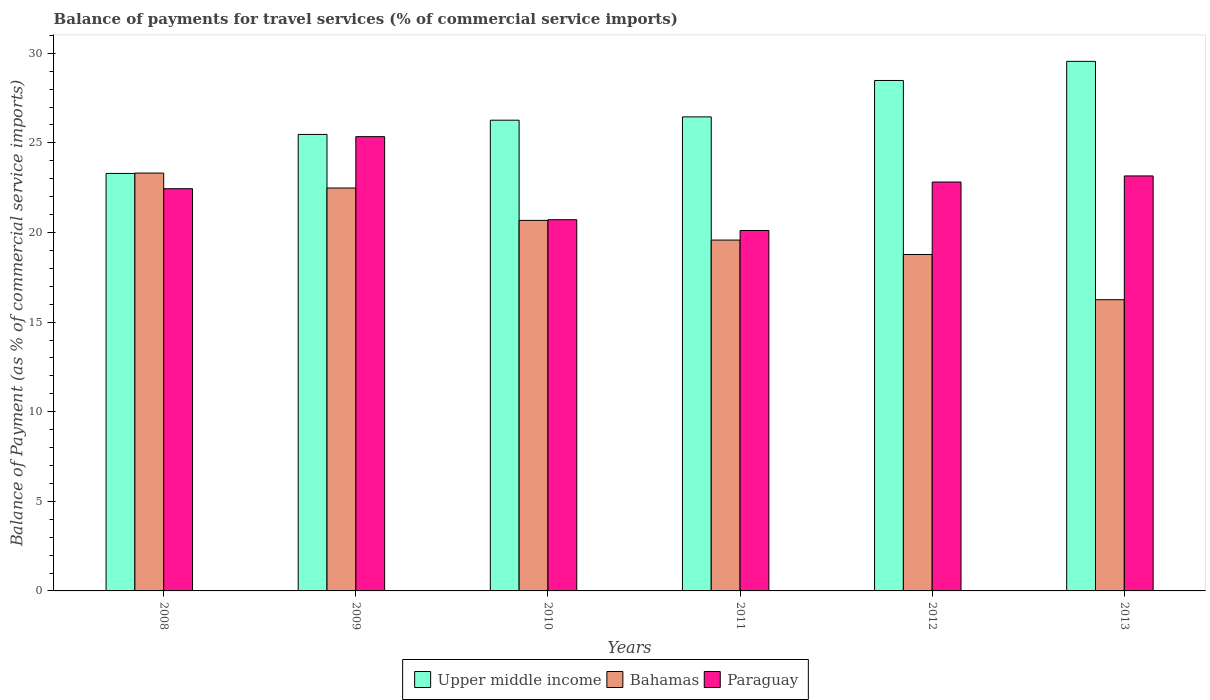How many different coloured bars are there?
Offer a terse response. 3. Are the number of bars on each tick of the X-axis equal?
Your answer should be compact. Yes. What is the label of the 3rd group of bars from the left?
Make the answer very short. 2010. What is the balance of payments for travel services in Paraguay in 2013?
Your answer should be compact. 23.16. Across all years, what is the maximum balance of payments for travel services in Bahamas?
Provide a succinct answer. 23.32. Across all years, what is the minimum balance of payments for travel services in Paraguay?
Provide a short and direct response. 20.11. In which year was the balance of payments for travel services in Upper middle income minimum?
Your answer should be very brief. 2008. What is the total balance of payments for travel services in Bahamas in the graph?
Your answer should be very brief. 121.08. What is the difference between the balance of payments for travel services in Upper middle income in 2009 and that in 2013?
Your answer should be very brief. -4.08. What is the difference between the balance of payments for travel services in Bahamas in 2008 and the balance of payments for travel services in Paraguay in 2011?
Your answer should be compact. 3.2. What is the average balance of payments for travel services in Paraguay per year?
Give a very brief answer. 22.43. In the year 2009, what is the difference between the balance of payments for travel services in Bahamas and balance of payments for travel services in Paraguay?
Your answer should be very brief. -2.87. In how many years, is the balance of payments for travel services in Bahamas greater than 19 %?
Your answer should be compact. 4. What is the ratio of the balance of payments for travel services in Bahamas in 2008 to that in 2011?
Provide a succinct answer. 1.19. Is the difference between the balance of payments for travel services in Bahamas in 2009 and 2012 greater than the difference between the balance of payments for travel services in Paraguay in 2009 and 2012?
Give a very brief answer. Yes. What is the difference between the highest and the second highest balance of payments for travel services in Upper middle income?
Offer a terse response. 1.07. What is the difference between the highest and the lowest balance of payments for travel services in Bahamas?
Your answer should be very brief. 7.07. What does the 1st bar from the left in 2012 represents?
Provide a succinct answer. Upper middle income. What does the 2nd bar from the right in 2013 represents?
Make the answer very short. Bahamas. How many bars are there?
Provide a short and direct response. 18. Are all the bars in the graph horizontal?
Your response must be concise. No. What is the difference between two consecutive major ticks on the Y-axis?
Keep it short and to the point. 5. Are the values on the major ticks of Y-axis written in scientific E-notation?
Make the answer very short. No. What is the title of the graph?
Make the answer very short. Balance of payments for travel services (% of commercial service imports). Does "Euro area" appear as one of the legend labels in the graph?
Make the answer very short. No. What is the label or title of the Y-axis?
Your response must be concise. Balance of Payment (as % of commercial service imports). What is the Balance of Payment (as % of commercial service imports) in Upper middle income in 2008?
Keep it short and to the point. 23.3. What is the Balance of Payment (as % of commercial service imports) in Bahamas in 2008?
Provide a succinct answer. 23.32. What is the Balance of Payment (as % of commercial service imports) in Paraguay in 2008?
Make the answer very short. 22.44. What is the Balance of Payment (as % of commercial service imports) in Upper middle income in 2009?
Give a very brief answer. 25.47. What is the Balance of Payment (as % of commercial service imports) in Bahamas in 2009?
Provide a succinct answer. 22.48. What is the Balance of Payment (as % of commercial service imports) in Paraguay in 2009?
Your response must be concise. 25.35. What is the Balance of Payment (as % of commercial service imports) in Upper middle income in 2010?
Ensure brevity in your answer.  26.27. What is the Balance of Payment (as % of commercial service imports) in Bahamas in 2010?
Your response must be concise. 20.68. What is the Balance of Payment (as % of commercial service imports) of Paraguay in 2010?
Offer a very short reply. 20.71. What is the Balance of Payment (as % of commercial service imports) in Upper middle income in 2011?
Provide a short and direct response. 26.45. What is the Balance of Payment (as % of commercial service imports) of Bahamas in 2011?
Provide a short and direct response. 19.58. What is the Balance of Payment (as % of commercial service imports) in Paraguay in 2011?
Provide a short and direct response. 20.11. What is the Balance of Payment (as % of commercial service imports) of Upper middle income in 2012?
Your response must be concise. 28.48. What is the Balance of Payment (as % of commercial service imports) in Bahamas in 2012?
Offer a terse response. 18.77. What is the Balance of Payment (as % of commercial service imports) of Paraguay in 2012?
Provide a short and direct response. 22.82. What is the Balance of Payment (as % of commercial service imports) of Upper middle income in 2013?
Provide a succinct answer. 29.55. What is the Balance of Payment (as % of commercial service imports) of Bahamas in 2013?
Provide a succinct answer. 16.25. What is the Balance of Payment (as % of commercial service imports) of Paraguay in 2013?
Make the answer very short. 23.16. Across all years, what is the maximum Balance of Payment (as % of commercial service imports) in Upper middle income?
Make the answer very short. 29.55. Across all years, what is the maximum Balance of Payment (as % of commercial service imports) in Bahamas?
Offer a terse response. 23.32. Across all years, what is the maximum Balance of Payment (as % of commercial service imports) in Paraguay?
Make the answer very short. 25.35. Across all years, what is the minimum Balance of Payment (as % of commercial service imports) in Upper middle income?
Your answer should be compact. 23.3. Across all years, what is the minimum Balance of Payment (as % of commercial service imports) in Bahamas?
Make the answer very short. 16.25. Across all years, what is the minimum Balance of Payment (as % of commercial service imports) in Paraguay?
Give a very brief answer. 20.11. What is the total Balance of Payment (as % of commercial service imports) in Upper middle income in the graph?
Offer a terse response. 159.52. What is the total Balance of Payment (as % of commercial service imports) in Bahamas in the graph?
Offer a very short reply. 121.08. What is the total Balance of Payment (as % of commercial service imports) of Paraguay in the graph?
Provide a short and direct response. 134.59. What is the difference between the Balance of Payment (as % of commercial service imports) in Upper middle income in 2008 and that in 2009?
Provide a short and direct response. -2.18. What is the difference between the Balance of Payment (as % of commercial service imports) in Bahamas in 2008 and that in 2009?
Provide a short and direct response. 0.83. What is the difference between the Balance of Payment (as % of commercial service imports) in Paraguay in 2008 and that in 2009?
Provide a succinct answer. -2.9. What is the difference between the Balance of Payment (as % of commercial service imports) of Upper middle income in 2008 and that in 2010?
Your answer should be very brief. -2.97. What is the difference between the Balance of Payment (as % of commercial service imports) of Bahamas in 2008 and that in 2010?
Provide a succinct answer. 2.64. What is the difference between the Balance of Payment (as % of commercial service imports) of Paraguay in 2008 and that in 2010?
Offer a terse response. 1.73. What is the difference between the Balance of Payment (as % of commercial service imports) in Upper middle income in 2008 and that in 2011?
Your answer should be very brief. -3.15. What is the difference between the Balance of Payment (as % of commercial service imports) of Bahamas in 2008 and that in 2011?
Provide a succinct answer. 3.74. What is the difference between the Balance of Payment (as % of commercial service imports) in Paraguay in 2008 and that in 2011?
Your answer should be compact. 2.33. What is the difference between the Balance of Payment (as % of commercial service imports) of Upper middle income in 2008 and that in 2012?
Offer a very short reply. -5.19. What is the difference between the Balance of Payment (as % of commercial service imports) of Bahamas in 2008 and that in 2012?
Keep it short and to the point. 4.54. What is the difference between the Balance of Payment (as % of commercial service imports) of Paraguay in 2008 and that in 2012?
Your answer should be compact. -0.37. What is the difference between the Balance of Payment (as % of commercial service imports) of Upper middle income in 2008 and that in 2013?
Your response must be concise. -6.25. What is the difference between the Balance of Payment (as % of commercial service imports) of Bahamas in 2008 and that in 2013?
Keep it short and to the point. 7.07. What is the difference between the Balance of Payment (as % of commercial service imports) of Paraguay in 2008 and that in 2013?
Your answer should be very brief. -0.71. What is the difference between the Balance of Payment (as % of commercial service imports) in Upper middle income in 2009 and that in 2010?
Your answer should be compact. -0.79. What is the difference between the Balance of Payment (as % of commercial service imports) in Bahamas in 2009 and that in 2010?
Your answer should be very brief. 1.81. What is the difference between the Balance of Payment (as % of commercial service imports) in Paraguay in 2009 and that in 2010?
Give a very brief answer. 4.64. What is the difference between the Balance of Payment (as % of commercial service imports) of Upper middle income in 2009 and that in 2011?
Your answer should be compact. -0.98. What is the difference between the Balance of Payment (as % of commercial service imports) in Bahamas in 2009 and that in 2011?
Provide a succinct answer. 2.91. What is the difference between the Balance of Payment (as % of commercial service imports) in Paraguay in 2009 and that in 2011?
Your response must be concise. 5.24. What is the difference between the Balance of Payment (as % of commercial service imports) of Upper middle income in 2009 and that in 2012?
Provide a succinct answer. -3.01. What is the difference between the Balance of Payment (as % of commercial service imports) of Bahamas in 2009 and that in 2012?
Make the answer very short. 3.71. What is the difference between the Balance of Payment (as % of commercial service imports) in Paraguay in 2009 and that in 2012?
Provide a short and direct response. 2.53. What is the difference between the Balance of Payment (as % of commercial service imports) of Upper middle income in 2009 and that in 2013?
Give a very brief answer. -4.08. What is the difference between the Balance of Payment (as % of commercial service imports) of Bahamas in 2009 and that in 2013?
Your answer should be compact. 6.23. What is the difference between the Balance of Payment (as % of commercial service imports) of Paraguay in 2009 and that in 2013?
Your answer should be very brief. 2.19. What is the difference between the Balance of Payment (as % of commercial service imports) of Upper middle income in 2010 and that in 2011?
Your answer should be very brief. -0.18. What is the difference between the Balance of Payment (as % of commercial service imports) in Bahamas in 2010 and that in 2011?
Ensure brevity in your answer.  1.1. What is the difference between the Balance of Payment (as % of commercial service imports) of Paraguay in 2010 and that in 2011?
Provide a succinct answer. 0.6. What is the difference between the Balance of Payment (as % of commercial service imports) of Upper middle income in 2010 and that in 2012?
Provide a short and direct response. -2.22. What is the difference between the Balance of Payment (as % of commercial service imports) in Bahamas in 2010 and that in 2012?
Your response must be concise. 1.9. What is the difference between the Balance of Payment (as % of commercial service imports) of Paraguay in 2010 and that in 2012?
Offer a terse response. -2.1. What is the difference between the Balance of Payment (as % of commercial service imports) of Upper middle income in 2010 and that in 2013?
Ensure brevity in your answer.  -3.28. What is the difference between the Balance of Payment (as % of commercial service imports) of Bahamas in 2010 and that in 2013?
Offer a terse response. 4.43. What is the difference between the Balance of Payment (as % of commercial service imports) of Paraguay in 2010 and that in 2013?
Provide a succinct answer. -2.44. What is the difference between the Balance of Payment (as % of commercial service imports) in Upper middle income in 2011 and that in 2012?
Keep it short and to the point. -2.03. What is the difference between the Balance of Payment (as % of commercial service imports) of Bahamas in 2011 and that in 2012?
Your answer should be very brief. 0.8. What is the difference between the Balance of Payment (as % of commercial service imports) of Paraguay in 2011 and that in 2012?
Offer a very short reply. -2.71. What is the difference between the Balance of Payment (as % of commercial service imports) of Upper middle income in 2011 and that in 2013?
Provide a short and direct response. -3.1. What is the difference between the Balance of Payment (as % of commercial service imports) in Bahamas in 2011 and that in 2013?
Give a very brief answer. 3.33. What is the difference between the Balance of Payment (as % of commercial service imports) in Paraguay in 2011 and that in 2013?
Keep it short and to the point. -3.04. What is the difference between the Balance of Payment (as % of commercial service imports) in Upper middle income in 2012 and that in 2013?
Ensure brevity in your answer.  -1.07. What is the difference between the Balance of Payment (as % of commercial service imports) of Bahamas in 2012 and that in 2013?
Offer a very short reply. 2.52. What is the difference between the Balance of Payment (as % of commercial service imports) of Paraguay in 2012 and that in 2013?
Your answer should be very brief. -0.34. What is the difference between the Balance of Payment (as % of commercial service imports) of Upper middle income in 2008 and the Balance of Payment (as % of commercial service imports) of Bahamas in 2009?
Give a very brief answer. 0.81. What is the difference between the Balance of Payment (as % of commercial service imports) in Upper middle income in 2008 and the Balance of Payment (as % of commercial service imports) in Paraguay in 2009?
Provide a succinct answer. -2.05. What is the difference between the Balance of Payment (as % of commercial service imports) in Bahamas in 2008 and the Balance of Payment (as % of commercial service imports) in Paraguay in 2009?
Provide a succinct answer. -2.03. What is the difference between the Balance of Payment (as % of commercial service imports) in Upper middle income in 2008 and the Balance of Payment (as % of commercial service imports) in Bahamas in 2010?
Your answer should be very brief. 2.62. What is the difference between the Balance of Payment (as % of commercial service imports) of Upper middle income in 2008 and the Balance of Payment (as % of commercial service imports) of Paraguay in 2010?
Give a very brief answer. 2.58. What is the difference between the Balance of Payment (as % of commercial service imports) in Bahamas in 2008 and the Balance of Payment (as % of commercial service imports) in Paraguay in 2010?
Make the answer very short. 2.6. What is the difference between the Balance of Payment (as % of commercial service imports) in Upper middle income in 2008 and the Balance of Payment (as % of commercial service imports) in Bahamas in 2011?
Your response must be concise. 3.72. What is the difference between the Balance of Payment (as % of commercial service imports) in Upper middle income in 2008 and the Balance of Payment (as % of commercial service imports) in Paraguay in 2011?
Provide a short and direct response. 3.18. What is the difference between the Balance of Payment (as % of commercial service imports) of Bahamas in 2008 and the Balance of Payment (as % of commercial service imports) of Paraguay in 2011?
Ensure brevity in your answer.  3.2. What is the difference between the Balance of Payment (as % of commercial service imports) in Upper middle income in 2008 and the Balance of Payment (as % of commercial service imports) in Bahamas in 2012?
Your answer should be very brief. 4.52. What is the difference between the Balance of Payment (as % of commercial service imports) in Upper middle income in 2008 and the Balance of Payment (as % of commercial service imports) in Paraguay in 2012?
Your answer should be compact. 0.48. What is the difference between the Balance of Payment (as % of commercial service imports) in Bahamas in 2008 and the Balance of Payment (as % of commercial service imports) in Paraguay in 2012?
Provide a succinct answer. 0.5. What is the difference between the Balance of Payment (as % of commercial service imports) in Upper middle income in 2008 and the Balance of Payment (as % of commercial service imports) in Bahamas in 2013?
Offer a very short reply. 7.05. What is the difference between the Balance of Payment (as % of commercial service imports) of Upper middle income in 2008 and the Balance of Payment (as % of commercial service imports) of Paraguay in 2013?
Offer a very short reply. 0.14. What is the difference between the Balance of Payment (as % of commercial service imports) in Bahamas in 2008 and the Balance of Payment (as % of commercial service imports) in Paraguay in 2013?
Offer a very short reply. 0.16. What is the difference between the Balance of Payment (as % of commercial service imports) of Upper middle income in 2009 and the Balance of Payment (as % of commercial service imports) of Bahamas in 2010?
Your answer should be very brief. 4.8. What is the difference between the Balance of Payment (as % of commercial service imports) of Upper middle income in 2009 and the Balance of Payment (as % of commercial service imports) of Paraguay in 2010?
Your response must be concise. 4.76. What is the difference between the Balance of Payment (as % of commercial service imports) of Bahamas in 2009 and the Balance of Payment (as % of commercial service imports) of Paraguay in 2010?
Give a very brief answer. 1.77. What is the difference between the Balance of Payment (as % of commercial service imports) of Upper middle income in 2009 and the Balance of Payment (as % of commercial service imports) of Bahamas in 2011?
Your answer should be very brief. 5.89. What is the difference between the Balance of Payment (as % of commercial service imports) of Upper middle income in 2009 and the Balance of Payment (as % of commercial service imports) of Paraguay in 2011?
Give a very brief answer. 5.36. What is the difference between the Balance of Payment (as % of commercial service imports) of Bahamas in 2009 and the Balance of Payment (as % of commercial service imports) of Paraguay in 2011?
Offer a terse response. 2.37. What is the difference between the Balance of Payment (as % of commercial service imports) of Upper middle income in 2009 and the Balance of Payment (as % of commercial service imports) of Bahamas in 2012?
Your answer should be very brief. 6.7. What is the difference between the Balance of Payment (as % of commercial service imports) in Upper middle income in 2009 and the Balance of Payment (as % of commercial service imports) in Paraguay in 2012?
Provide a short and direct response. 2.66. What is the difference between the Balance of Payment (as % of commercial service imports) in Bahamas in 2009 and the Balance of Payment (as % of commercial service imports) in Paraguay in 2012?
Provide a succinct answer. -0.33. What is the difference between the Balance of Payment (as % of commercial service imports) of Upper middle income in 2009 and the Balance of Payment (as % of commercial service imports) of Bahamas in 2013?
Give a very brief answer. 9.22. What is the difference between the Balance of Payment (as % of commercial service imports) in Upper middle income in 2009 and the Balance of Payment (as % of commercial service imports) in Paraguay in 2013?
Ensure brevity in your answer.  2.32. What is the difference between the Balance of Payment (as % of commercial service imports) in Bahamas in 2009 and the Balance of Payment (as % of commercial service imports) in Paraguay in 2013?
Offer a very short reply. -0.67. What is the difference between the Balance of Payment (as % of commercial service imports) of Upper middle income in 2010 and the Balance of Payment (as % of commercial service imports) of Bahamas in 2011?
Ensure brevity in your answer.  6.69. What is the difference between the Balance of Payment (as % of commercial service imports) in Upper middle income in 2010 and the Balance of Payment (as % of commercial service imports) in Paraguay in 2011?
Your answer should be compact. 6.15. What is the difference between the Balance of Payment (as % of commercial service imports) of Bahamas in 2010 and the Balance of Payment (as % of commercial service imports) of Paraguay in 2011?
Your answer should be very brief. 0.56. What is the difference between the Balance of Payment (as % of commercial service imports) of Upper middle income in 2010 and the Balance of Payment (as % of commercial service imports) of Bahamas in 2012?
Provide a succinct answer. 7.49. What is the difference between the Balance of Payment (as % of commercial service imports) of Upper middle income in 2010 and the Balance of Payment (as % of commercial service imports) of Paraguay in 2012?
Offer a terse response. 3.45. What is the difference between the Balance of Payment (as % of commercial service imports) of Bahamas in 2010 and the Balance of Payment (as % of commercial service imports) of Paraguay in 2012?
Ensure brevity in your answer.  -2.14. What is the difference between the Balance of Payment (as % of commercial service imports) of Upper middle income in 2010 and the Balance of Payment (as % of commercial service imports) of Bahamas in 2013?
Offer a very short reply. 10.02. What is the difference between the Balance of Payment (as % of commercial service imports) in Upper middle income in 2010 and the Balance of Payment (as % of commercial service imports) in Paraguay in 2013?
Provide a succinct answer. 3.11. What is the difference between the Balance of Payment (as % of commercial service imports) in Bahamas in 2010 and the Balance of Payment (as % of commercial service imports) in Paraguay in 2013?
Your answer should be very brief. -2.48. What is the difference between the Balance of Payment (as % of commercial service imports) of Upper middle income in 2011 and the Balance of Payment (as % of commercial service imports) of Bahamas in 2012?
Ensure brevity in your answer.  7.68. What is the difference between the Balance of Payment (as % of commercial service imports) of Upper middle income in 2011 and the Balance of Payment (as % of commercial service imports) of Paraguay in 2012?
Provide a short and direct response. 3.63. What is the difference between the Balance of Payment (as % of commercial service imports) of Bahamas in 2011 and the Balance of Payment (as % of commercial service imports) of Paraguay in 2012?
Offer a terse response. -3.24. What is the difference between the Balance of Payment (as % of commercial service imports) of Upper middle income in 2011 and the Balance of Payment (as % of commercial service imports) of Bahamas in 2013?
Ensure brevity in your answer.  10.2. What is the difference between the Balance of Payment (as % of commercial service imports) of Upper middle income in 2011 and the Balance of Payment (as % of commercial service imports) of Paraguay in 2013?
Your answer should be very brief. 3.29. What is the difference between the Balance of Payment (as % of commercial service imports) of Bahamas in 2011 and the Balance of Payment (as % of commercial service imports) of Paraguay in 2013?
Make the answer very short. -3.58. What is the difference between the Balance of Payment (as % of commercial service imports) of Upper middle income in 2012 and the Balance of Payment (as % of commercial service imports) of Bahamas in 2013?
Provide a short and direct response. 12.23. What is the difference between the Balance of Payment (as % of commercial service imports) in Upper middle income in 2012 and the Balance of Payment (as % of commercial service imports) in Paraguay in 2013?
Keep it short and to the point. 5.33. What is the difference between the Balance of Payment (as % of commercial service imports) of Bahamas in 2012 and the Balance of Payment (as % of commercial service imports) of Paraguay in 2013?
Offer a terse response. -4.38. What is the average Balance of Payment (as % of commercial service imports) of Upper middle income per year?
Offer a terse response. 26.59. What is the average Balance of Payment (as % of commercial service imports) in Bahamas per year?
Give a very brief answer. 20.18. What is the average Balance of Payment (as % of commercial service imports) of Paraguay per year?
Offer a very short reply. 22.43. In the year 2008, what is the difference between the Balance of Payment (as % of commercial service imports) of Upper middle income and Balance of Payment (as % of commercial service imports) of Bahamas?
Make the answer very short. -0.02. In the year 2008, what is the difference between the Balance of Payment (as % of commercial service imports) of Upper middle income and Balance of Payment (as % of commercial service imports) of Paraguay?
Give a very brief answer. 0.85. In the year 2008, what is the difference between the Balance of Payment (as % of commercial service imports) in Bahamas and Balance of Payment (as % of commercial service imports) in Paraguay?
Offer a terse response. 0.87. In the year 2009, what is the difference between the Balance of Payment (as % of commercial service imports) of Upper middle income and Balance of Payment (as % of commercial service imports) of Bahamas?
Offer a very short reply. 2.99. In the year 2009, what is the difference between the Balance of Payment (as % of commercial service imports) of Upper middle income and Balance of Payment (as % of commercial service imports) of Paraguay?
Ensure brevity in your answer.  0.12. In the year 2009, what is the difference between the Balance of Payment (as % of commercial service imports) in Bahamas and Balance of Payment (as % of commercial service imports) in Paraguay?
Your answer should be compact. -2.87. In the year 2010, what is the difference between the Balance of Payment (as % of commercial service imports) in Upper middle income and Balance of Payment (as % of commercial service imports) in Bahamas?
Offer a terse response. 5.59. In the year 2010, what is the difference between the Balance of Payment (as % of commercial service imports) in Upper middle income and Balance of Payment (as % of commercial service imports) in Paraguay?
Keep it short and to the point. 5.55. In the year 2010, what is the difference between the Balance of Payment (as % of commercial service imports) in Bahamas and Balance of Payment (as % of commercial service imports) in Paraguay?
Make the answer very short. -0.04. In the year 2011, what is the difference between the Balance of Payment (as % of commercial service imports) in Upper middle income and Balance of Payment (as % of commercial service imports) in Bahamas?
Offer a terse response. 6.87. In the year 2011, what is the difference between the Balance of Payment (as % of commercial service imports) of Upper middle income and Balance of Payment (as % of commercial service imports) of Paraguay?
Your response must be concise. 6.34. In the year 2011, what is the difference between the Balance of Payment (as % of commercial service imports) of Bahamas and Balance of Payment (as % of commercial service imports) of Paraguay?
Provide a succinct answer. -0.53. In the year 2012, what is the difference between the Balance of Payment (as % of commercial service imports) in Upper middle income and Balance of Payment (as % of commercial service imports) in Bahamas?
Provide a short and direct response. 9.71. In the year 2012, what is the difference between the Balance of Payment (as % of commercial service imports) in Upper middle income and Balance of Payment (as % of commercial service imports) in Paraguay?
Offer a terse response. 5.67. In the year 2012, what is the difference between the Balance of Payment (as % of commercial service imports) of Bahamas and Balance of Payment (as % of commercial service imports) of Paraguay?
Your answer should be very brief. -4.04. In the year 2013, what is the difference between the Balance of Payment (as % of commercial service imports) in Upper middle income and Balance of Payment (as % of commercial service imports) in Bahamas?
Make the answer very short. 13.3. In the year 2013, what is the difference between the Balance of Payment (as % of commercial service imports) in Upper middle income and Balance of Payment (as % of commercial service imports) in Paraguay?
Offer a very short reply. 6.39. In the year 2013, what is the difference between the Balance of Payment (as % of commercial service imports) in Bahamas and Balance of Payment (as % of commercial service imports) in Paraguay?
Offer a very short reply. -6.91. What is the ratio of the Balance of Payment (as % of commercial service imports) in Upper middle income in 2008 to that in 2009?
Your answer should be very brief. 0.91. What is the ratio of the Balance of Payment (as % of commercial service imports) in Bahamas in 2008 to that in 2009?
Keep it short and to the point. 1.04. What is the ratio of the Balance of Payment (as % of commercial service imports) of Paraguay in 2008 to that in 2009?
Your response must be concise. 0.89. What is the ratio of the Balance of Payment (as % of commercial service imports) of Upper middle income in 2008 to that in 2010?
Offer a terse response. 0.89. What is the ratio of the Balance of Payment (as % of commercial service imports) of Bahamas in 2008 to that in 2010?
Keep it short and to the point. 1.13. What is the ratio of the Balance of Payment (as % of commercial service imports) of Paraguay in 2008 to that in 2010?
Ensure brevity in your answer.  1.08. What is the ratio of the Balance of Payment (as % of commercial service imports) of Upper middle income in 2008 to that in 2011?
Offer a very short reply. 0.88. What is the ratio of the Balance of Payment (as % of commercial service imports) of Bahamas in 2008 to that in 2011?
Keep it short and to the point. 1.19. What is the ratio of the Balance of Payment (as % of commercial service imports) of Paraguay in 2008 to that in 2011?
Offer a terse response. 1.12. What is the ratio of the Balance of Payment (as % of commercial service imports) in Upper middle income in 2008 to that in 2012?
Your response must be concise. 0.82. What is the ratio of the Balance of Payment (as % of commercial service imports) of Bahamas in 2008 to that in 2012?
Give a very brief answer. 1.24. What is the ratio of the Balance of Payment (as % of commercial service imports) of Paraguay in 2008 to that in 2012?
Provide a short and direct response. 0.98. What is the ratio of the Balance of Payment (as % of commercial service imports) of Upper middle income in 2008 to that in 2013?
Your response must be concise. 0.79. What is the ratio of the Balance of Payment (as % of commercial service imports) in Bahamas in 2008 to that in 2013?
Make the answer very short. 1.43. What is the ratio of the Balance of Payment (as % of commercial service imports) of Paraguay in 2008 to that in 2013?
Provide a succinct answer. 0.97. What is the ratio of the Balance of Payment (as % of commercial service imports) of Upper middle income in 2009 to that in 2010?
Your response must be concise. 0.97. What is the ratio of the Balance of Payment (as % of commercial service imports) of Bahamas in 2009 to that in 2010?
Provide a short and direct response. 1.09. What is the ratio of the Balance of Payment (as % of commercial service imports) in Paraguay in 2009 to that in 2010?
Your answer should be very brief. 1.22. What is the ratio of the Balance of Payment (as % of commercial service imports) in Upper middle income in 2009 to that in 2011?
Your answer should be very brief. 0.96. What is the ratio of the Balance of Payment (as % of commercial service imports) of Bahamas in 2009 to that in 2011?
Give a very brief answer. 1.15. What is the ratio of the Balance of Payment (as % of commercial service imports) of Paraguay in 2009 to that in 2011?
Make the answer very short. 1.26. What is the ratio of the Balance of Payment (as % of commercial service imports) in Upper middle income in 2009 to that in 2012?
Keep it short and to the point. 0.89. What is the ratio of the Balance of Payment (as % of commercial service imports) of Bahamas in 2009 to that in 2012?
Your answer should be very brief. 1.2. What is the ratio of the Balance of Payment (as % of commercial service imports) of Paraguay in 2009 to that in 2012?
Provide a short and direct response. 1.11. What is the ratio of the Balance of Payment (as % of commercial service imports) in Upper middle income in 2009 to that in 2013?
Your answer should be compact. 0.86. What is the ratio of the Balance of Payment (as % of commercial service imports) of Bahamas in 2009 to that in 2013?
Provide a succinct answer. 1.38. What is the ratio of the Balance of Payment (as % of commercial service imports) of Paraguay in 2009 to that in 2013?
Offer a very short reply. 1.09. What is the ratio of the Balance of Payment (as % of commercial service imports) in Bahamas in 2010 to that in 2011?
Your answer should be compact. 1.06. What is the ratio of the Balance of Payment (as % of commercial service imports) in Paraguay in 2010 to that in 2011?
Give a very brief answer. 1.03. What is the ratio of the Balance of Payment (as % of commercial service imports) of Upper middle income in 2010 to that in 2012?
Your answer should be compact. 0.92. What is the ratio of the Balance of Payment (as % of commercial service imports) of Bahamas in 2010 to that in 2012?
Make the answer very short. 1.1. What is the ratio of the Balance of Payment (as % of commercial service imports) in Paraguay in 2010 to that in 2012?
Offer a terse response. 0.91. What is the ratio of the Balance of Payment (as % of commercial service imports) of Upper middle income in 2010 to that in 2013?
Give a very brief answer. 0.89. What is the ratio of the Balance of Payment (as % of commercial service imports) in Bahamas in 2010 to that in 2013?
Offer a very short reply. 1.27. What is the ratio of the Balance of Payment (as % of commercial service imports) in Paraguay in 2010 to that in 2013?
Ensure brevity in your answer.  0.89. What is the ratio of the Balance of Payment (as % of commercial service imports) of Upper middle income in 2011 to that in 2012?
Provide a succinct answer. 0.93. What is the ratio of the Balance of Payment (as % of commercial service imports) in Bahamas in 2011 to that in 2012?
Make the answer very short. 1.04. What is the ratio of the Balance of Payment (as % of commercial service imports) of Paraguay in 2011 to that in 2012?
Your answer should be compact. 0.88. What is the ratio of the Balance of Payment (as % of commercial service imports) of Upper middle income in 2011 to that in 2013?
Keep it short and to the point. 0.9. What is the ratio of the Balance of Payment (as % of commercial service imports) in Bahamas in 2011 to that in 2013?
Provide a succinct answer. 1.2. What is the ratio of the Balance of Payment (as % of commercial service imports) in Paraguay in 2011 to that in 2013?
Offer a very short reply. 0.87. What is the ratio of the Balance of Payment (as % of commercial service imports) of Upper middle income in 2012 to that in 2013?
Provide a short and direct response. 0.96. What is the ratio of the Balance of Payment (as % of commercial service imports) of Bahamas in 2012 to that in 2013?
Keep it short and to the point. 1.16. What is the difference between the highest and the second highest Balance of Payment (as % of commercial service imports) of Upper middle income?
Provide a short and direct response. 1.07. What is the difference between the highest and the second highest Balance of Payment (as % of commercial service imports) of Bahamas?
Offer a very short reply. 0.83. What is the difference between the highest and the second highest Balance of Payment (as % of commercial service imports) of Paraguay?
Provide a short and direct response. 2.19. What is the difference between the highest and the lowest Balance of Payment (as % of commercial service imports) of Upper middle income?
Offer a terse response. 6.25. What is the difference between the highest and the lowest Balance of Payment (as % of commercial service imports) in Bahamas?
Ensure brevity in your answer.  7.07. What is the difference between the highest and the lowest Balance of Payment (as % of commercial service imports) of Paraguay?
Your answer should be compact. 5.24. 